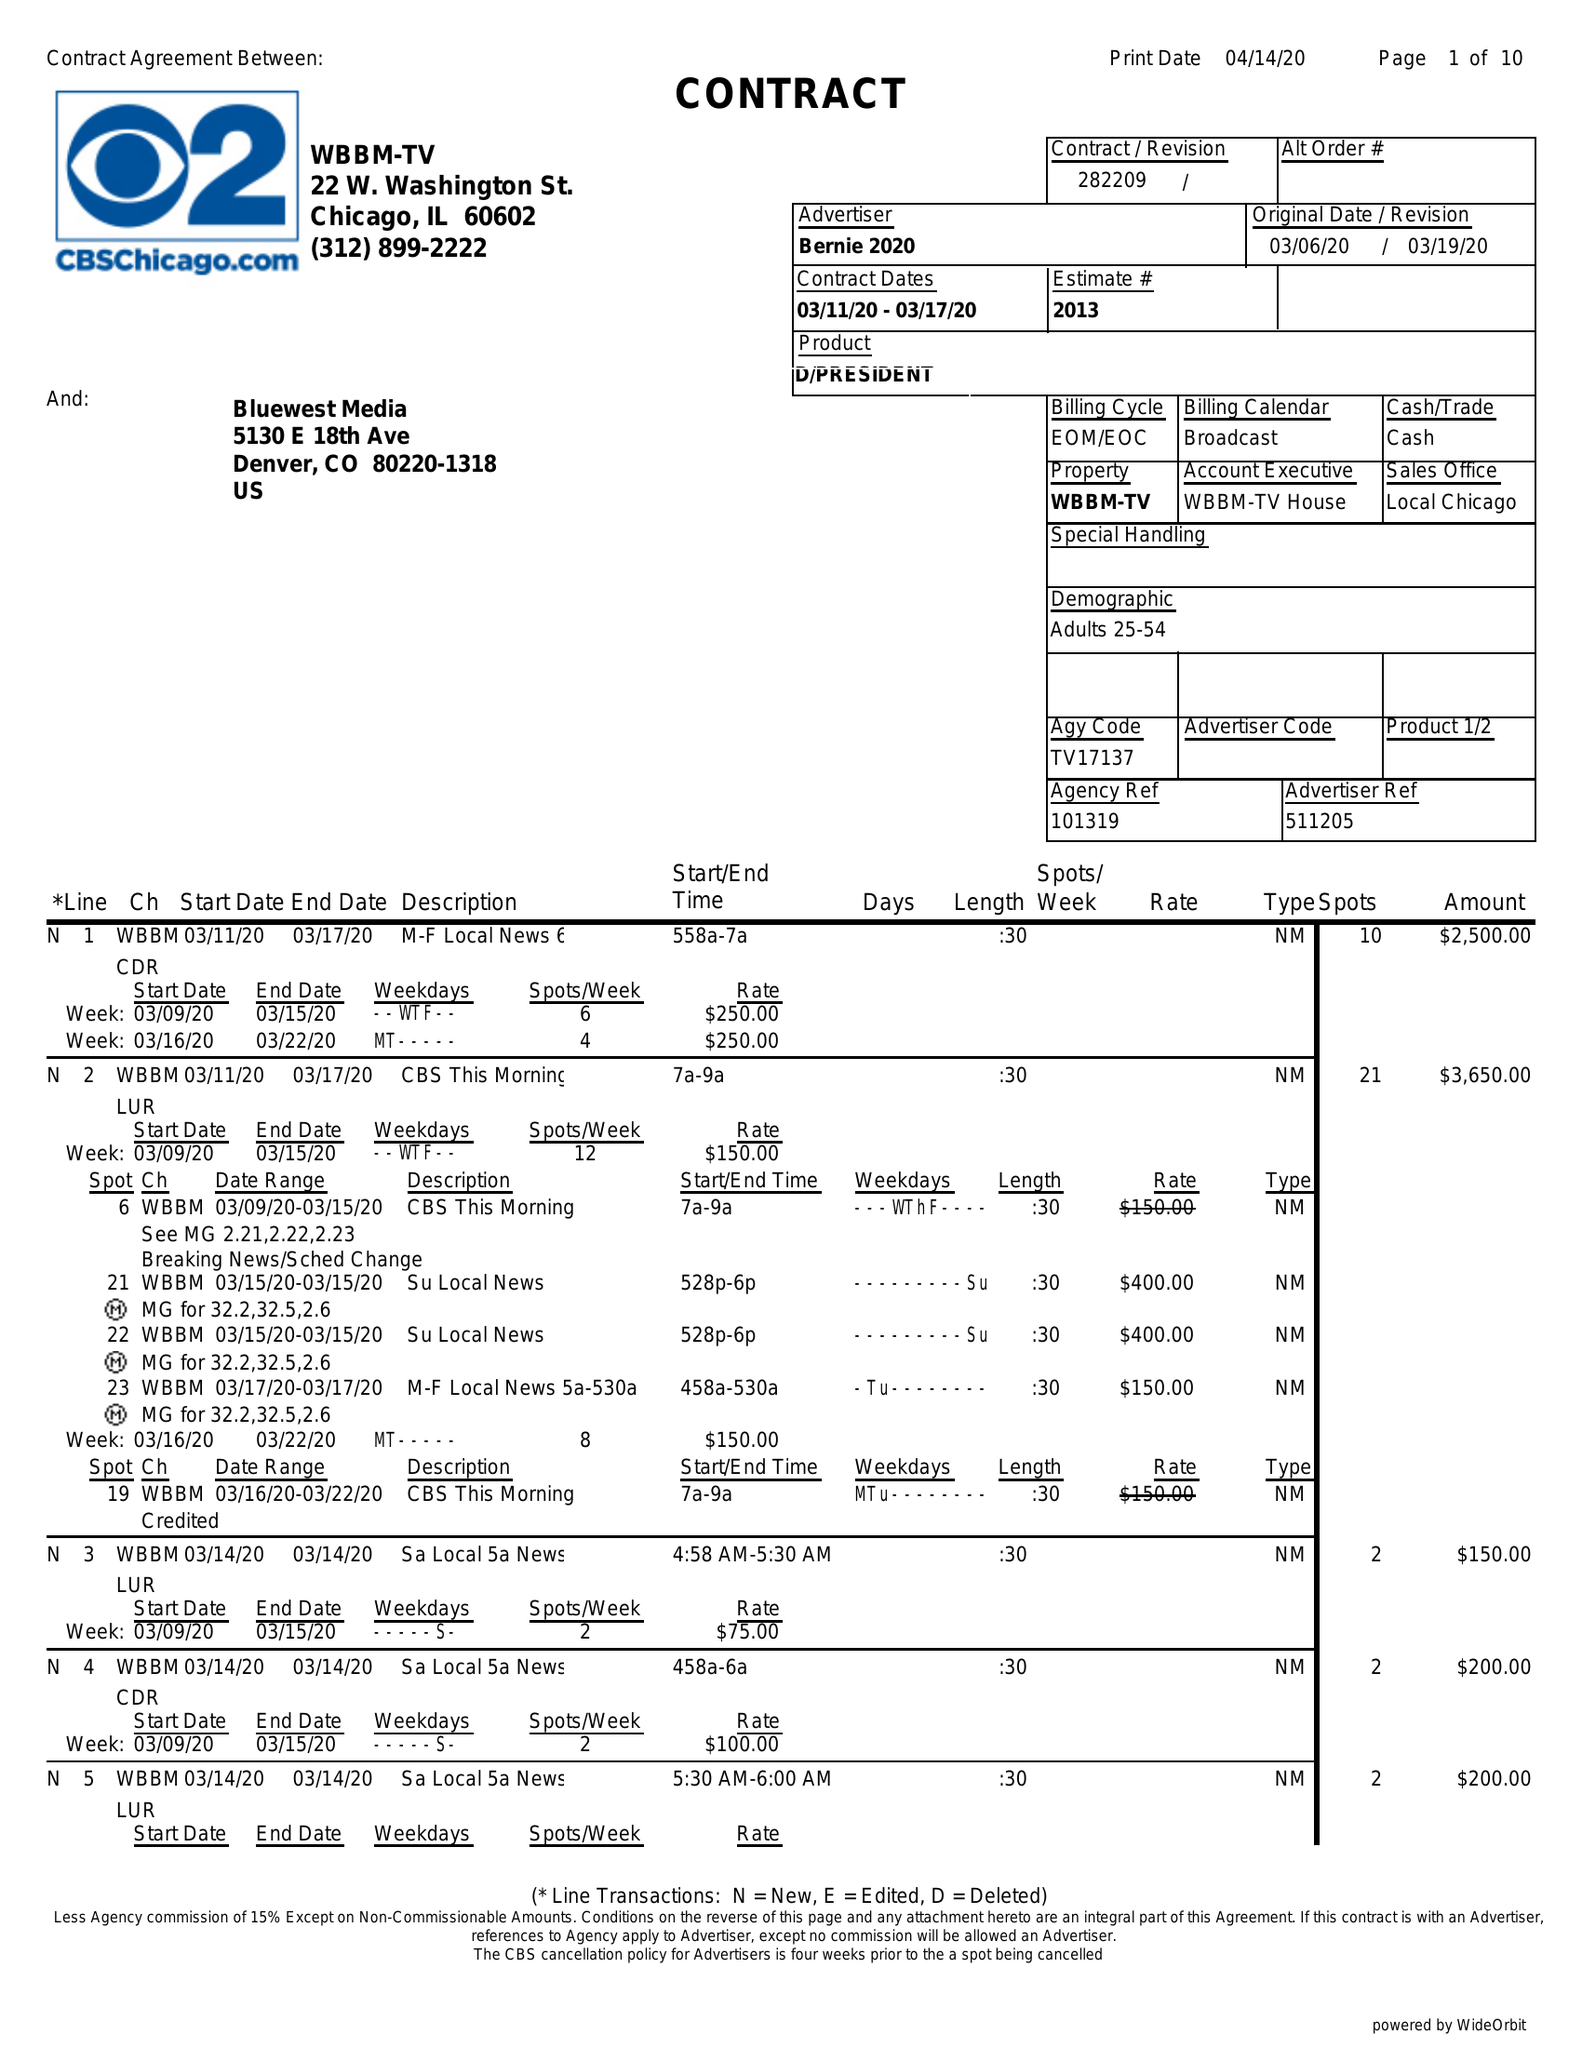What is the value for the contract_num?
Answer the question using a single word or phrase. 282209 